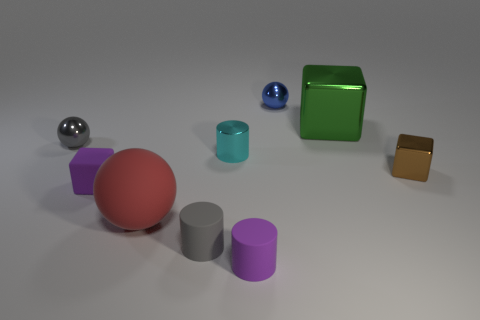Can you describe the colors and shapes of objects that seem to stand out in this arrangement? Certainly! In the image, the large red sphere stands out due to its size and vibrant color. Additionally, the green metallic cube is quite prominent because of its reflective surface and distinct color contrasting with the other objects. 